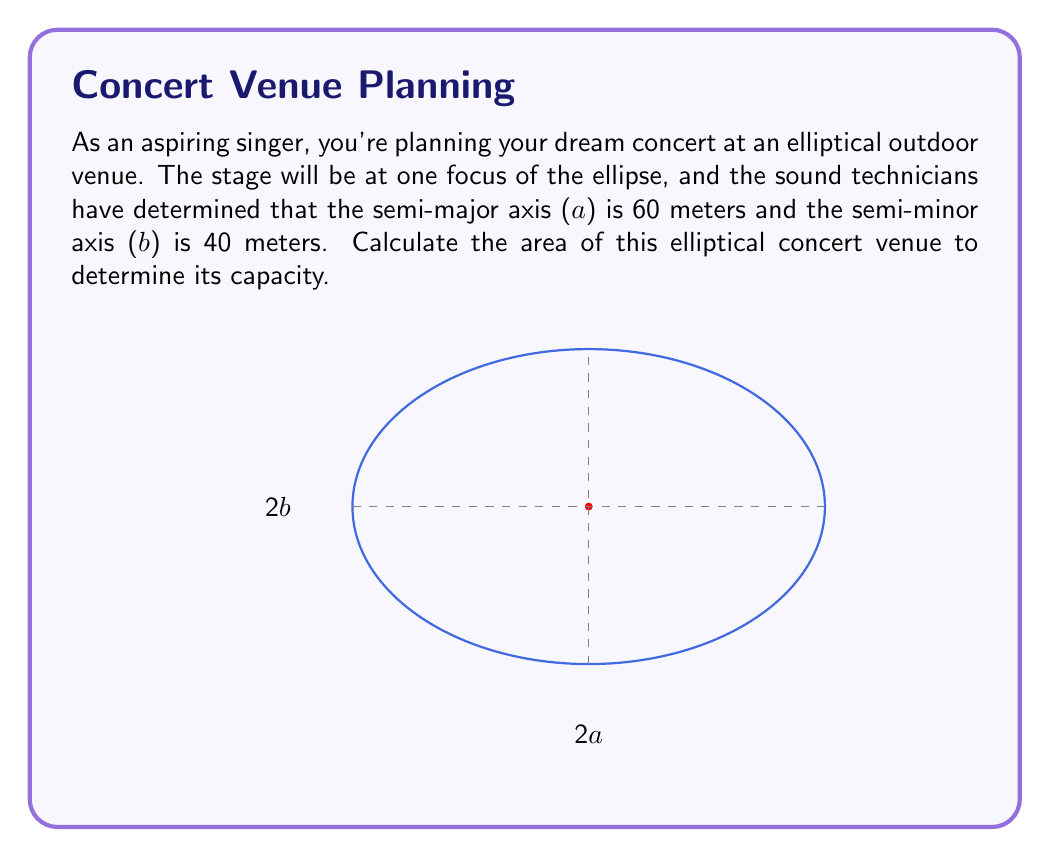Can you solve this math problem? To calculate the area of an ellipse, we use the formula:

$$A = \pi ab$$

Where:
$A$ is the area of the ellipse
$a$ is the length of the semi-major axis
$b$ is the length of the semi-minor axis
$\pi$ is approximately 3.14159

Given:
$a = 60$ meters
$b = 40$ meters

Let's substitute these values into the formula:

$$\begin{align}
A &= \pi ab \\
&= \pi (60)(40) \\
&= 2400\pi \text{ square meters}
\end{align}$$

To get a numerical value, we can use $\pi \approx 3.14159$:

$$\begin{align}
A &\approx 2400 \times 3.14159 \\
&\approx 7539.82 \text{ square meters}
\end{align}$$

Therefore, the area of the elliptical concert venue is approximately 7539.82 square meters.
Answer: $2400\pi$ square meters or approximately 7539.82 square meters 